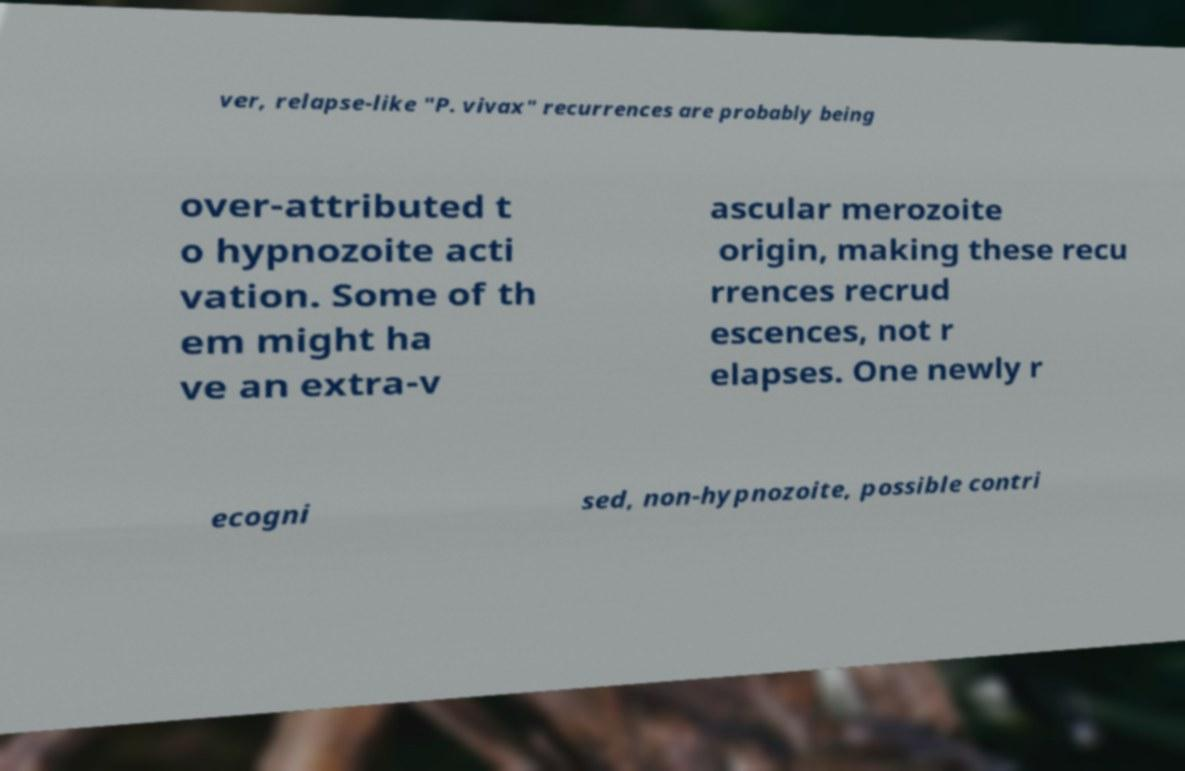Please read and relay the text visible in this image. What does it say? ver, relapse-like "P. vivax" recurrences are probably being over-attributed t o hypnozoite acti vation. Some of th em might ha ve an extra-v ascular merozoite origin, making these recu rrences recrud escences, not r elapses. One newly r ecogni sed, non-hypnozoite, possible contri 